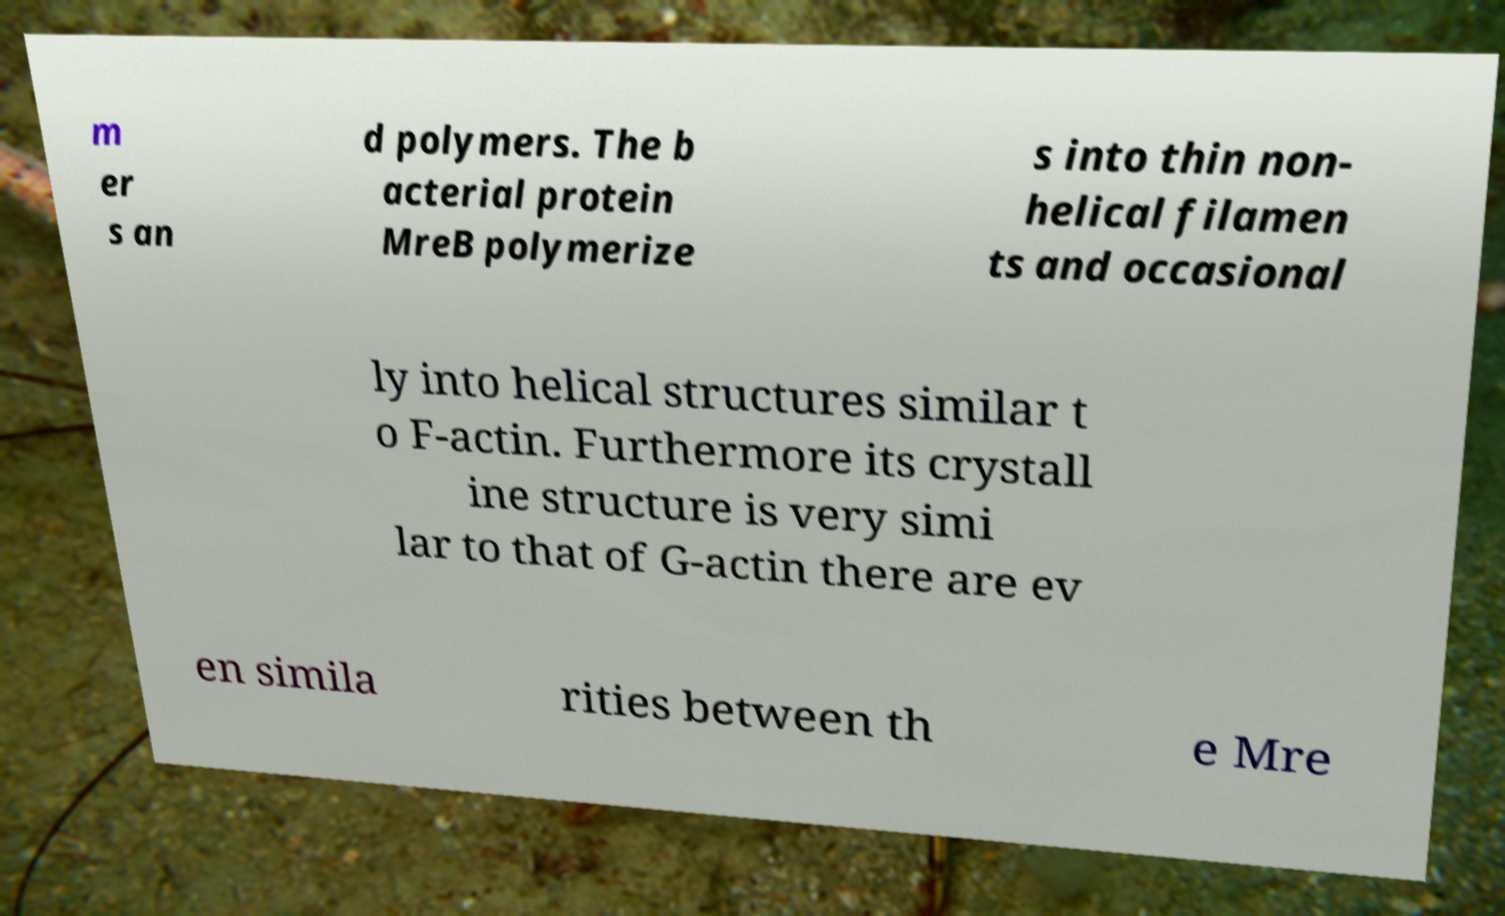For documentation purposes, I need the text within this image transcribed. Could you provide that? m er s an d polymers. The b acterial protein MreB polymerize s into thin non- helical filamen ts and occasional ly into helical structures similar t o F-actin. Furthermore its crystall ine structure is very simi lar to that of G-actin there are ev en simila rities between th e Mre 